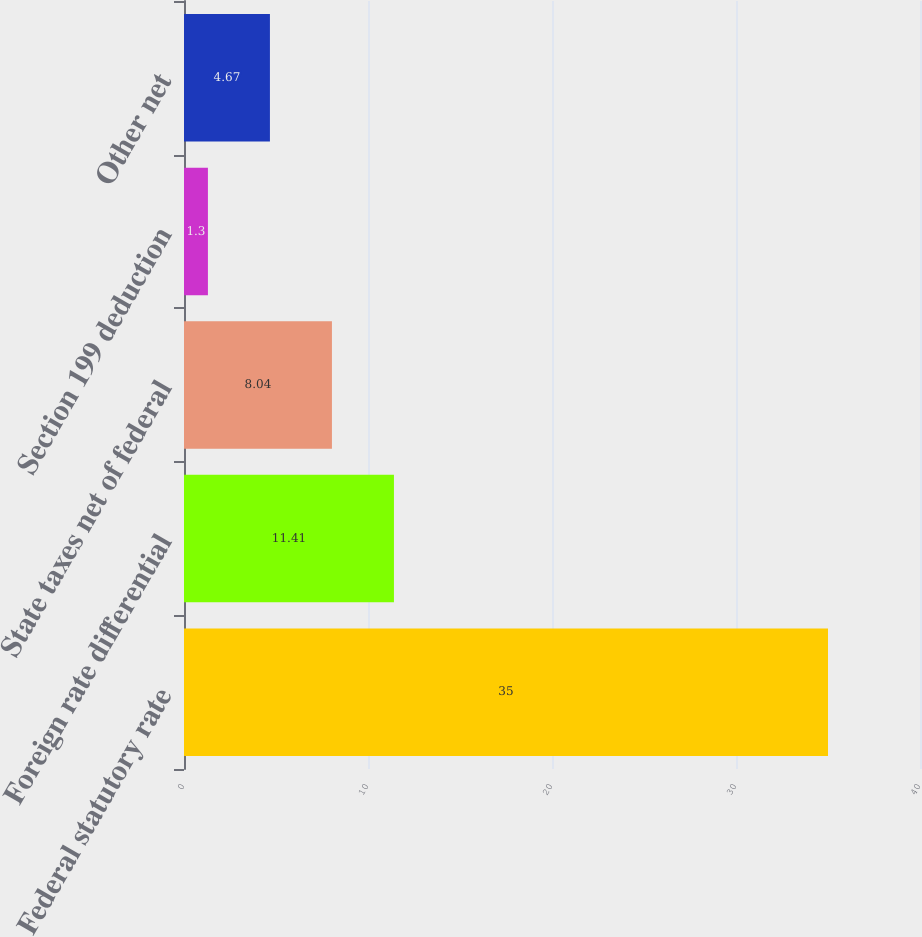Convert chart. <chart><loc_0><loc_0><loc_500><loc_500><bar_chart><fcel>Federal statutory rate<fcel>Foreign rate differential<fcel>State taxes net of federal<fcel>Section 199 deduction<fcel>Other net<nl><fcel>35<fcel>11.41<fcel>8.04<fcel>1.3<fcel>4.67<nl></chart> 